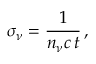Convert formula to latex. <formula><loc_0><loc_0><loc_500><loc_500>\sigma _ { \nu } = \frac { 1 } { n _ { \nu } c \, t } \, ,</formula> 